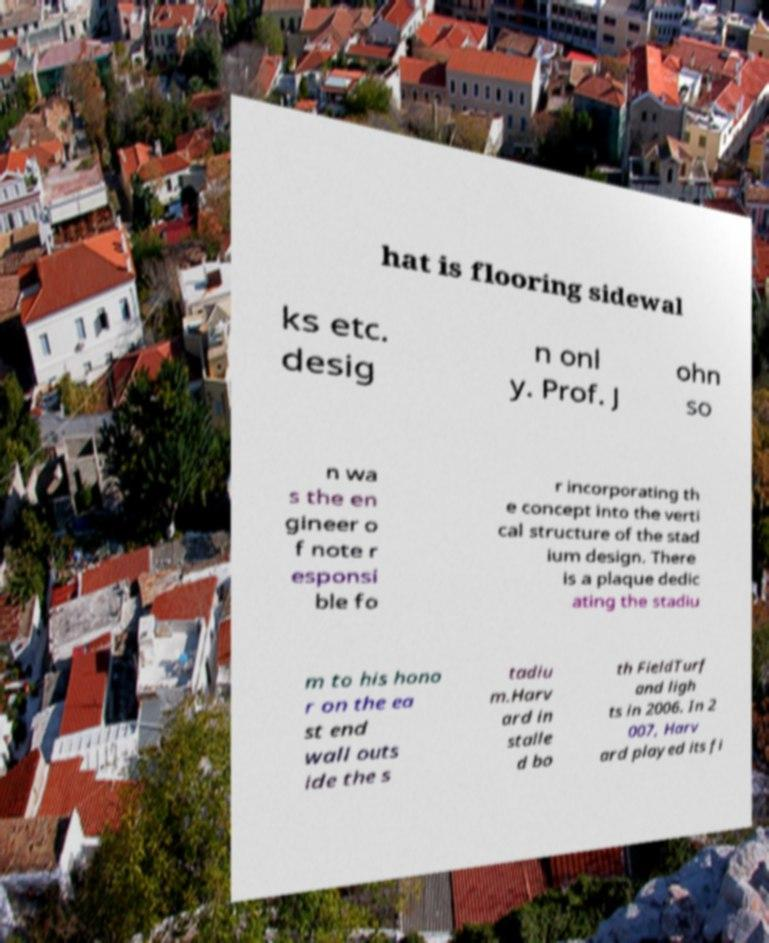For documentation purposes, I need the text within this image transcribed. Could you provide that? hat is flooring sidewal ks etc. desig n onl y. Prof. J ohn so n wa s the en gineer o f note r esponsi ble fo r incorporating th e concept into the verti cal structure of the stad ium design. There is a plaque dedic ating the stadiu m to his hono r on the ea st end wall outs ide the s tadiu m.Harv ard in stalle d bo th FieldTurf and ligh ts in 2006. In 2 007, Harv ard played its fi 